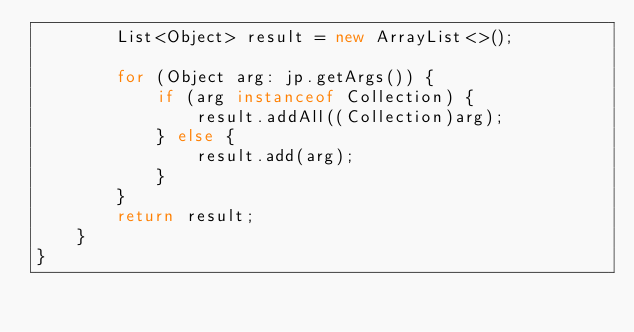Convert code to text. <code><loc_0><loc_0><loc_500><loc_500><_Java_>        List<Object> result = new ArrayList<>();

        for (Object arg: jp.getArgs()) {
            if (arg instanceof Collection) {
                result.addAll((Collection)arg);
            } else {
                result.add(arg);
            }
        }
        return result;
    }
}
</code> 